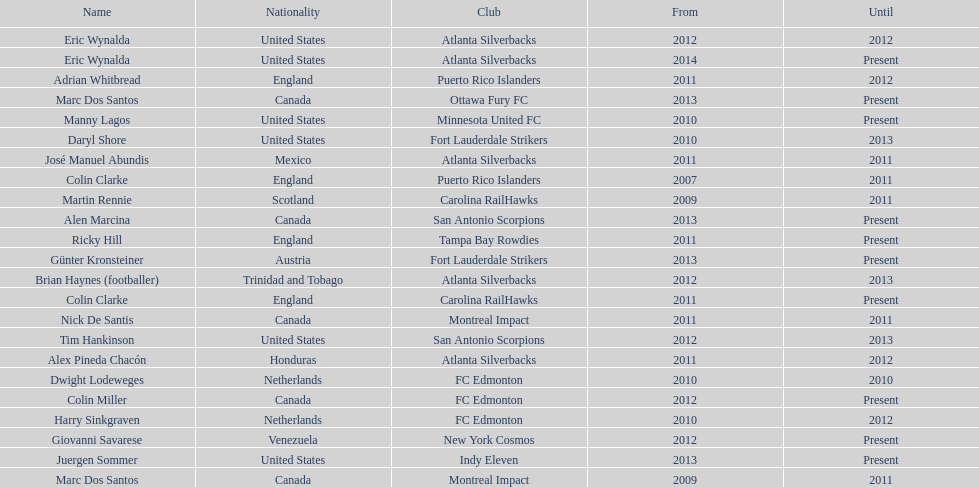Who was the coach of fc edmonton before miller? Harry Sinkgraven. 